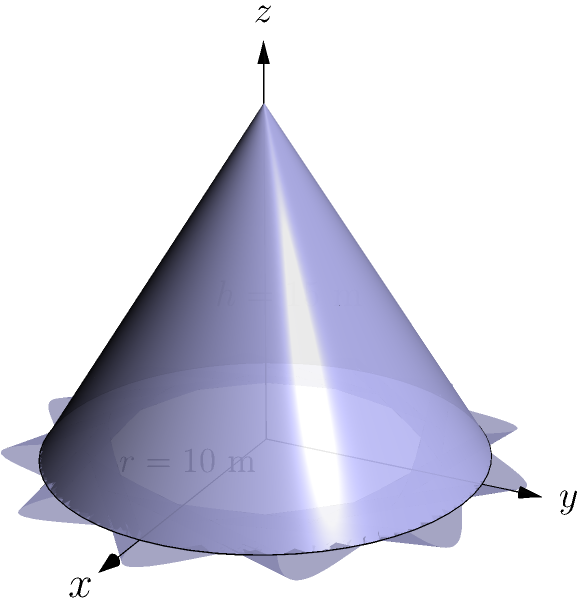At your stone and gravel quarry, you have a conical stockpile of gravel with a base radius of 10 meters and a height of 15 meters. What is the volume of this stockpile in cubic meters? Round your answer to the nearest whole number. To calculate the volume of a conical stockpile, we can use the formula for the volume of a cone:

$$V = \frac{1}{3}\pi r^2 h$$

Where:
$V$ = volume
$r$ = radius of the base
$h$ = height of the cone

Given:
$r = 10$ meters
$h = 15$ meters

Let's substitute these values into the formula:

$$V = \frac{1}{3}\pi (10\text{ m})^2 (15\text{ m})$$

$$V = \frac{1}{3}\pi (100\text{ m}^2) (15\text{ m})$$

$$V = 500\pi\text{ m}^3$$

Now, let's calculate this value:

$$V = 500 \times 3.14159... \text{ m}^3$$

$$V = 1570.7958...\text{ m}^3$$

Rounding to the nearest whole number:

$$V \approx 1571\text{ m}^3$$
Answer: 1571 m³ 